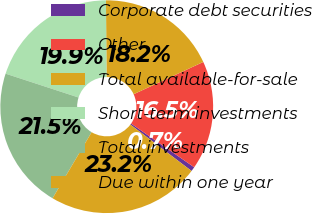<chart> <loc_0><loc_0><loc_500><loc_500><pie_chart><fcel>Corporate debt securities<fcel>Other<fcel>Total available-for-sale<fcel>Short-term investments<fcel>Total investments<fcel>Due within one year<nl><fcel>0.68%<fcel>16.55%<fcel>18.21%<fcel>19.86%<fcel>21.52%<fcel>23.18%<nl></chart> 